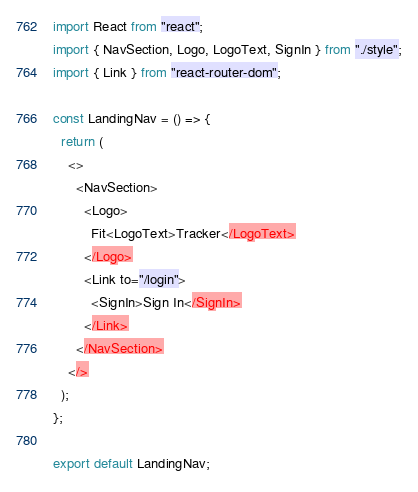<code> <loc_0><loc_0><loc_500><loc_500><_JavaScript_>import React from "react";
import { NavSection, Logo, LogoText, SignIn } from "./style";
import { Link } from "react-router-dom";

const LandingNav = () => {
  return (
    <>
      <NavSection>
        <Logo>
          Fit<LogoText>Tracker</LogoText>
        </Logo>
        <Link to="/login">
          <SignIn>Sign In</SignIn>
        </Link>
      </NavSection>
    </>
  );
};

export default LandingNav;
</code> 